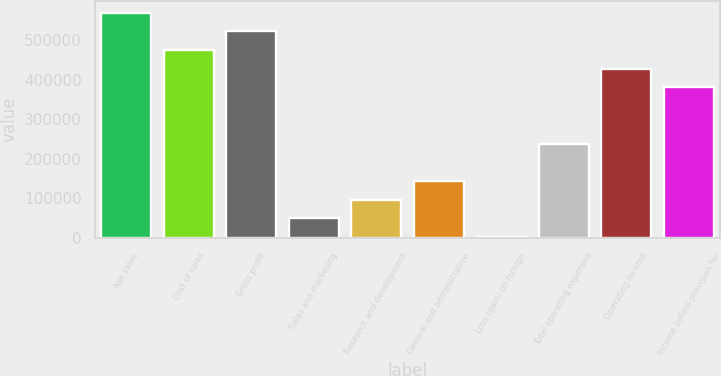<chart> <loc_0><loc_0><loc_500><loc_500><bar_chart><fcel>Net sales<fcel>Cost of sales<fcel>Gross profit<fcel>Sales and marketing<fcel>Research and development<fcel>General and administrative<fcel>Loss (gain) on foreign<fcel>Total operating expenses<fcel>Operating income<fcel>Income before provision for<nl><fcel>568806<fcel>474482<fcel>521644<fcel>50024<fcel>97186<fcel>144348<fcel>2862<fcel>238672<fcel>427320<fcel>380158<nl></chart> 